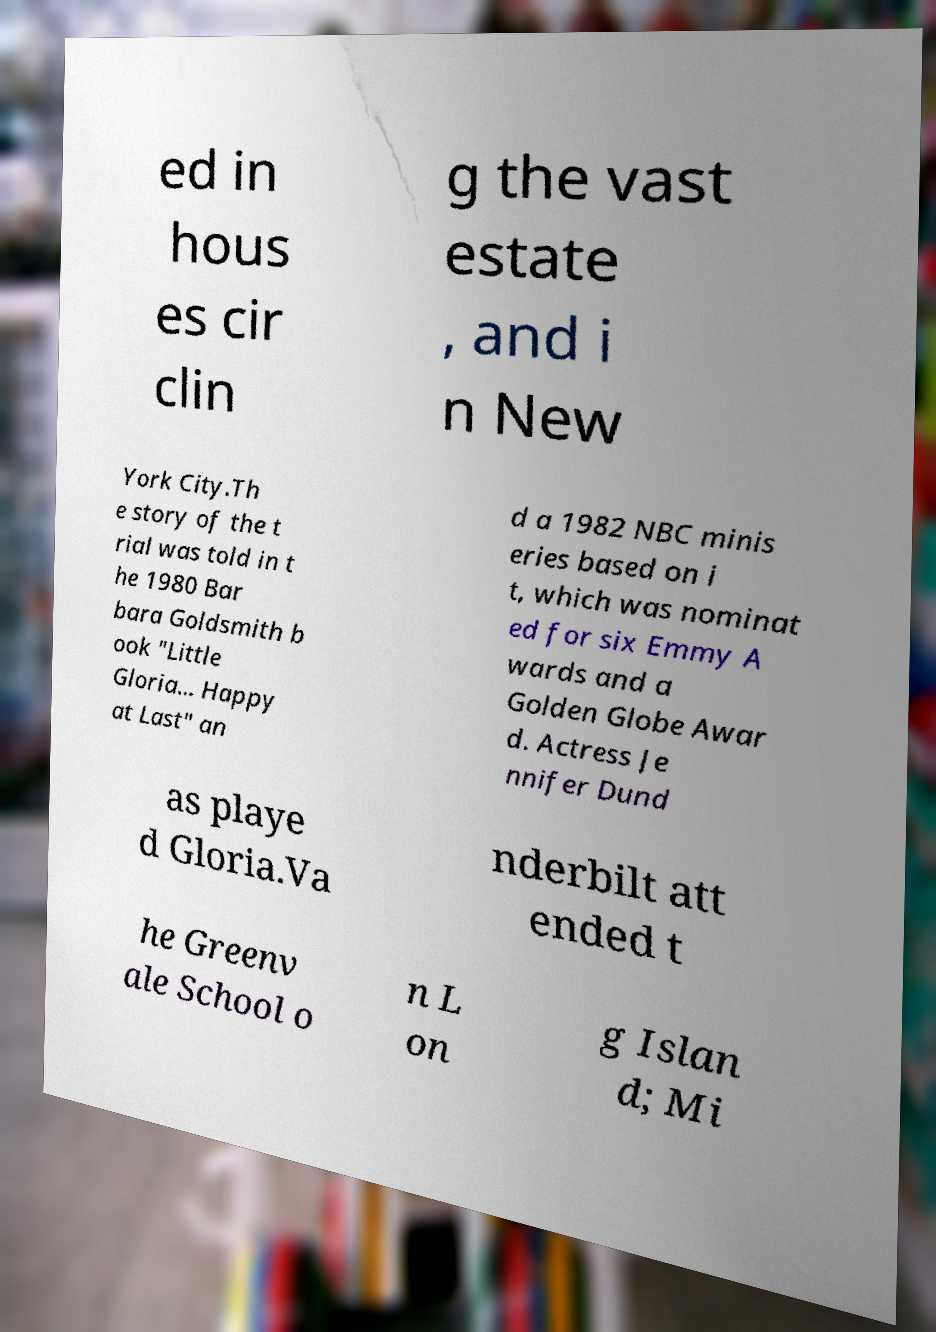There's text embedded in this image that I need extracted. Can you transcribe it verbatim? ed in hous es cir clin g the vast estate , and i n New York City.Th e story of the t rial was told in t he 1980 Bar bara Goldsmith b ook "Little Gloria... Happy at Last" an d a 1982 NBC minis eries based on i t, which was nominat ed for six Emmy A wards and a Golden Globe Awar d. Actress Je nnifer Dund as playe d Gloria.Va nderbilt att ended t he Greenv ale School o n L on g Islan d; Mi 